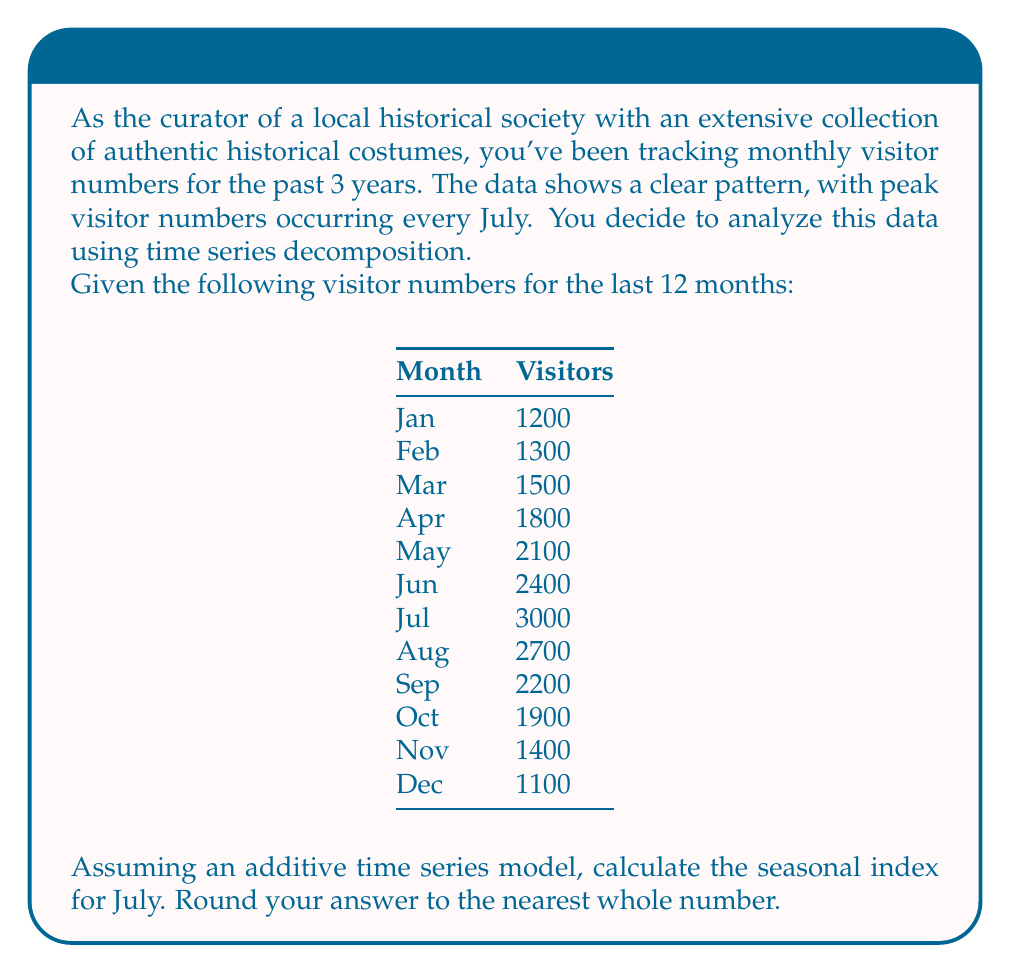Teach me how to tackle this problem. To calculate the seasonal index for July in an additive time series model, we'll follow these steps:

1. Calculate the average number of visitors per month:
   $$\text{Average} = \frac{1200 + 1300 + 1500 + 1800 + 2100 + 2400 + 3000 + 2700 + 2200 + 1900 + 1400 + 1100}{12} = 1883.33$$

2. In an additive model, the seasonal component is the difference between the observed value and the average. For July:
   $$\text{Seasonal component} = \text{Observed value} - \text{Average}$$
   $$\text{Seasonal component} = 3000 - 1883.33 = 1116.67$$

3. The seasonal index is typically expressed as a percentage or a whole number. In this case, we'll keep it as a whole number:
   $$\text{Seasonal index} = \text{round}(1116.67) = 1117$$

Therefore, the seasonal index for July, rounded to the nearest whole number, is 1117.

This index indicates that in July, the historical society typically receives 1117 more visitors than the average month, likely due to factors such as summer vacations, good weather, or special events related to historical costume displays during this period.
Answer: 1117 